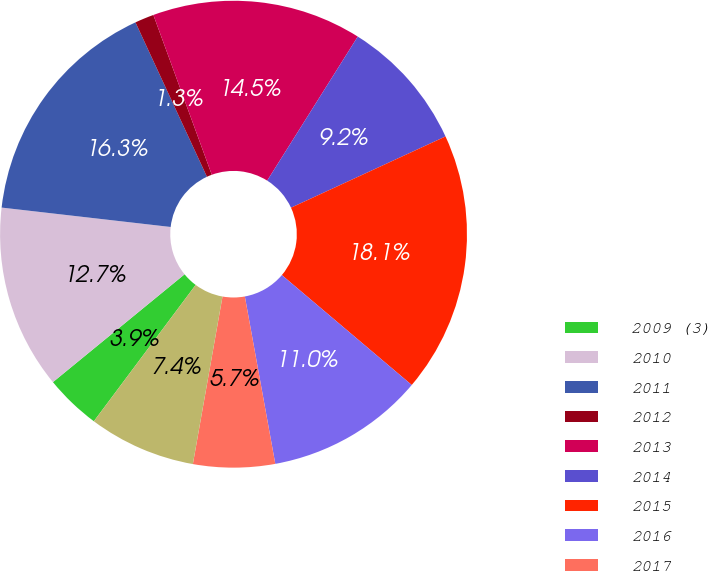<chart> <loc_0><loc_0><loc_500><loc_500><pie_chart><fcel>2009 (3)<fcel>2010<fcel>2011<fcel>2012<fcel>2013<fcel>2014<fcel>2015<fcel>2016<fcel>2017<fcel>2018<nl><fcel>3.87%<fcel>12.74%<fcel>16.28%<fcel>1.32%<fcel>14.51%<fcel>9.19%<fcel>18.05%<fcel>10.96%<fcel>5.65%<fcel>7.42%<nl></chart> 